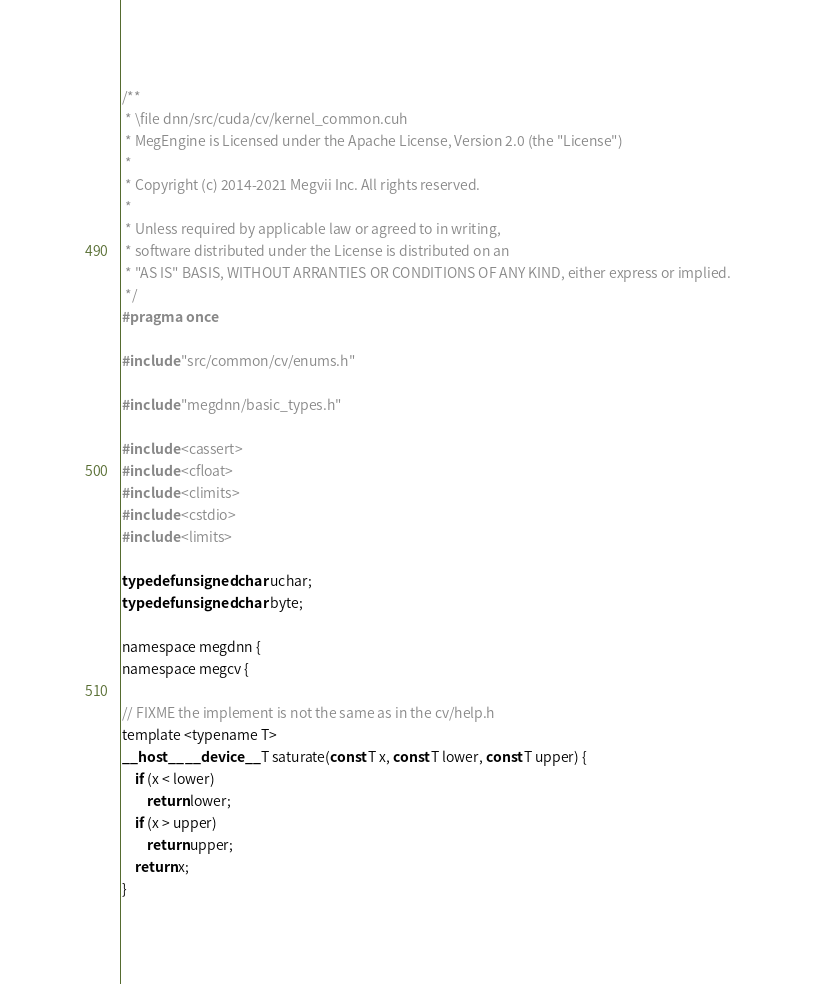<code> <loc_0><loc_0><loc_500><loc_500><_Cuda_>/**
 * \file dnn/src/cuda/cv/kernel_common.cuh
 * MegEngine is Licensed under the Apache License, Version 2.0 (the "License")
 *
 * Copyright (c) 2014-2021 Megvii Inc. All rights reserved.
 *
 * Unless required by applicable law or agreed to in writing,
 * software distributed under the License is distributed on an
 * "AS IS" BASIS, WITHOUT ARRANTIES OR CONDITIONS OF ANY KIND, either express or implied.
 */
#pragma once

#include "src/common/cv/enums.h"

#include "megdnn/basic_types.h"

#include <cassert>
#include <cfloat>
#include <climits>
#include <cstdio>
#include <limits>

typedef unsigned char uchar;
typedef unsigned char byte;

namespace megdnn {
namespace megcv {

// FIXME the implement is not the same as in the cv/help.h
template <typename T>
__host__ __device__ T saturate(const T x, const T lower, const T upper) {
    if (x < lower)
        return lower;
    if (x > upper)
        return upper;
    return x;
}
</code> 